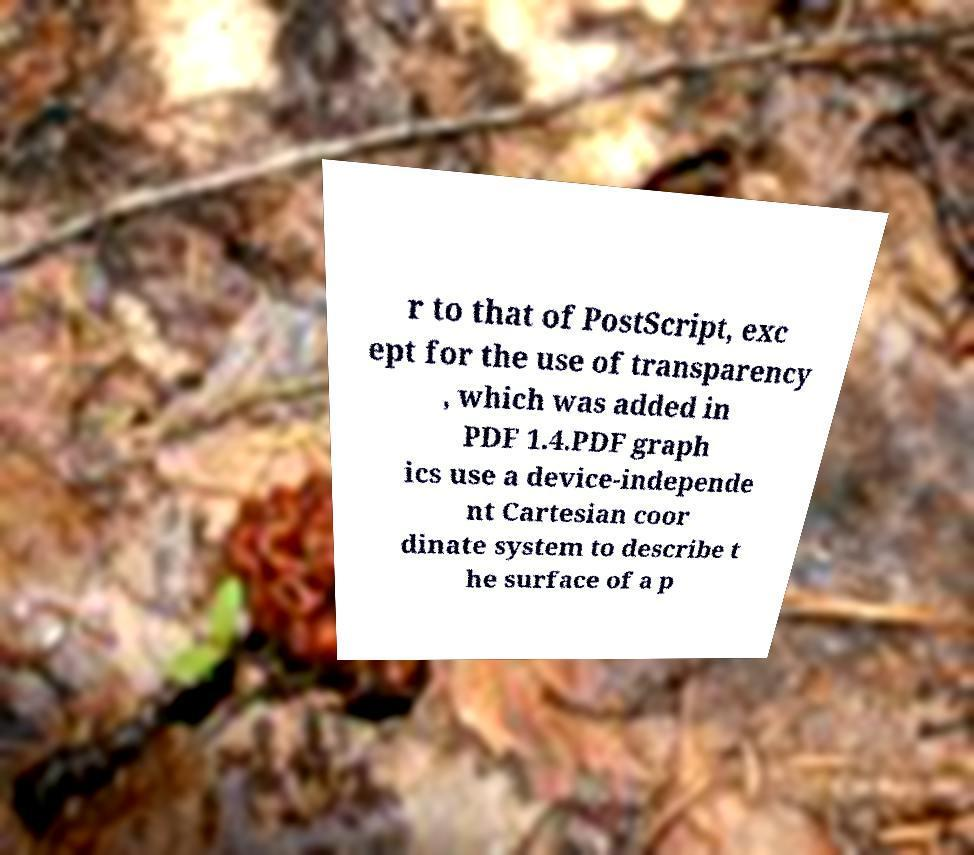There's text embedded in this image that I need extracted. Can you transcribe it verbatim? r to that of PostScript, exc ept for the use of transparency , which was added in PDF 1.4.PDF graph ics use a device-independe nt Cartesian coor dinate system to describe t he surface of a p 